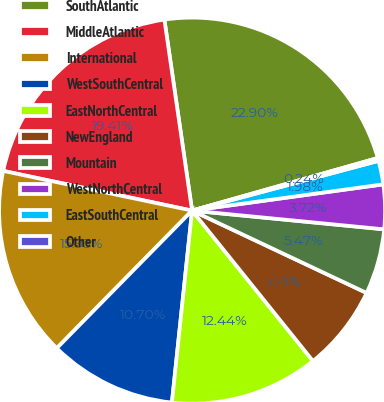<chart> <loc_0><loc_0><loc_500><loc_500><pie_chart><fcel>SouthAtlantic<fcel>MiddleAtlantic<fcel>International<fcel>WestSouthCentral<fcel>EastNorthCentral<fcel>NewEngland<fcel>Mountain<fcel>WestNorthCentral<fcel>EastSouthCentral<fcel>Other<nl><fcel>22.9%<fcel>19.41%<fcel>15.93%<fcel>10.7%<fcel>12.44%<fcel>7.21%<fcel>5.47%<fcel>3.72%<fcel>1.98%<fcel>0.24%<nl></chart> 